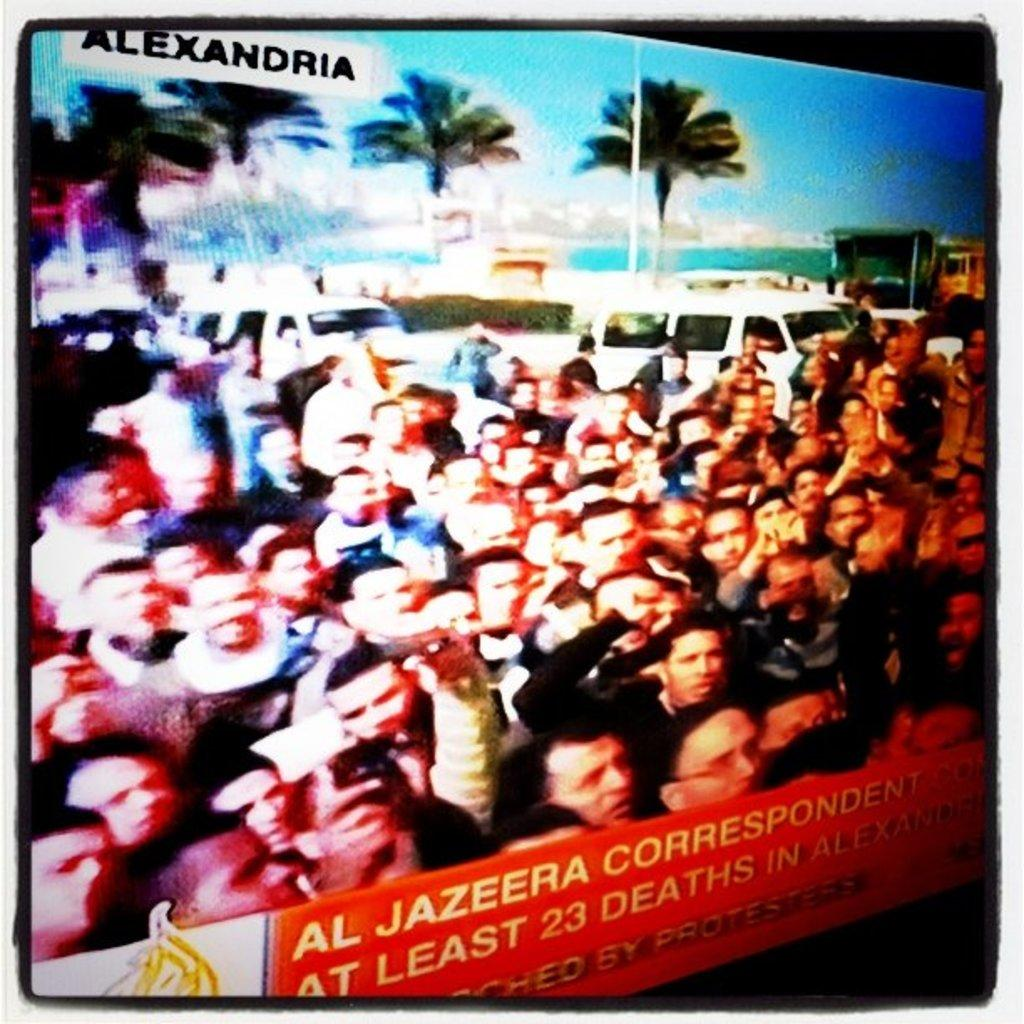<image>
Offer a succinct explanation of the picture presented. a TV screen of a crowd of people, with Alexandria and reporter AL JAZEERA talking about 23 deaths. 